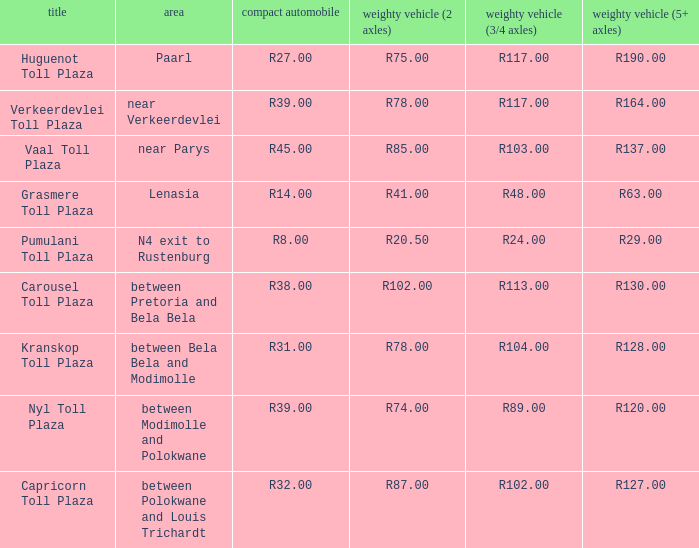What is the toll for light vehicles at the plaza where the toll for heavy vehicles with 2 axles is r87.00? R32.00. 